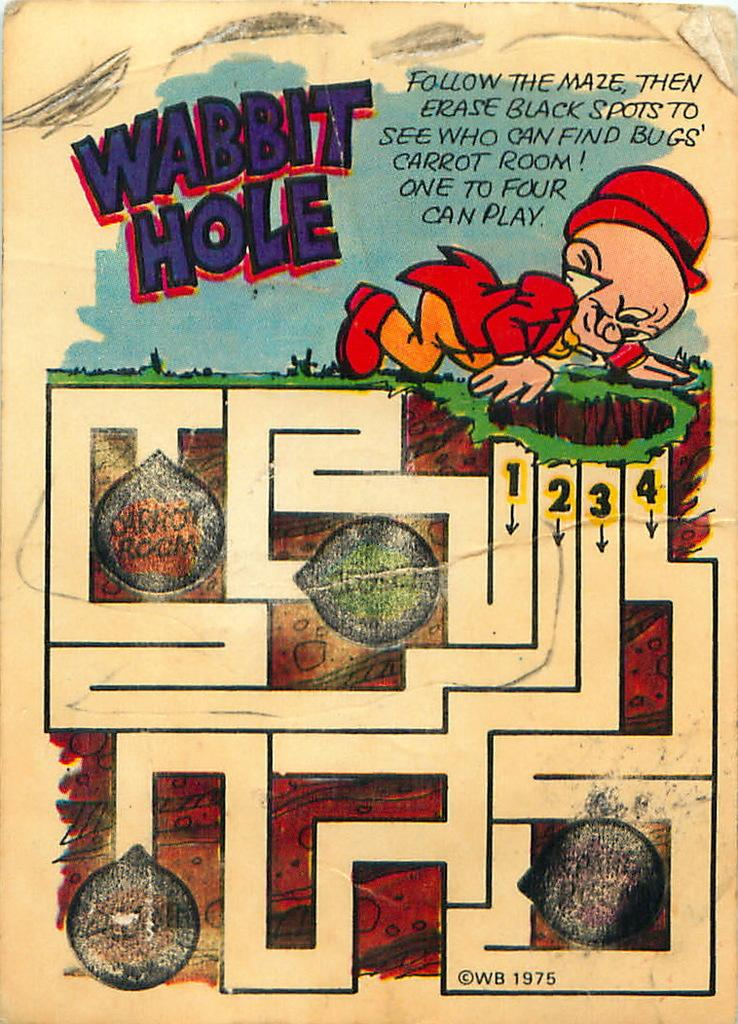<image>
Provide a brief description of the given image. An old Elmer Fudd children's coloring page titled 'Wabbit Hole'. 